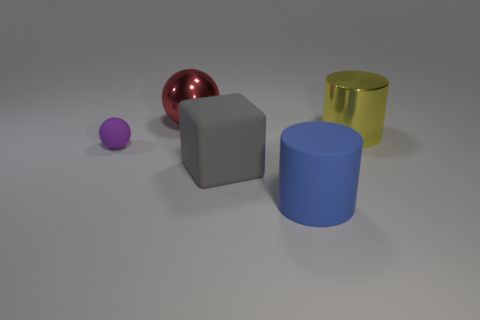Subtract all blue cylinders. How many cylinders are left? 1 Subtract 1 balls. How many balls are left? 1 Subtract all red cylinders. Subtract all blue balls. How many cylinders are left? 2 Subtract all green balls. How many yellow cylinders are left? 1 Add 3 blue metal cylinders. How many blue metal cylinders exist? 3 Add 1 big brown rubber objects. How many objects exist? 6 Subtract 0 green spheres. How many objects are left? 5 Subtract all cylinders. How many objects are left? 3 Subtract all big brown matte cylinders. Subtract all big blocks. How many objects are left? 4 Add 4 big blue rubber objects. How many big blue rubber objects are left? 5 